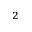<formula> <loc_0><loc_0><loc_500><loc_500>{ ^ { 2 } }</formula> 